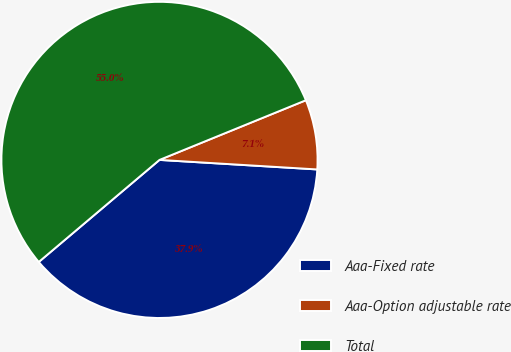<chart> <loc_0><loc_0><loc_500><loc_500><pie_chart><fcel>Aaa-Fixed rate<fcel>Aaa-Option adjustable rate<fcel>Total<nl><fcel>37.87%<fcel>7.12%<fcel>55.01%<nl></chart> 